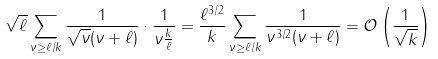<formula> <loc_0><loc_0><loc_500><loc_500>\sqrt { \ell } \sum _ { \nu \geq \ell / k } \frac { 1 } { \sqrt { \nu } ( \nu + \ell ) } \cdot \frac { 1 } { \nu \frac { k } { \ell } } = \frac { \ell ^ { 3 / 2 } } { k } \sum _ { \nu \geq \ell / k } \frac { 1 } { \nu ^ { 3 / 2 } ( \nu + \ell ) } = \mathcal { O } \left ( \frac { 1 } { \sqrt { k } } \right )</formula> 